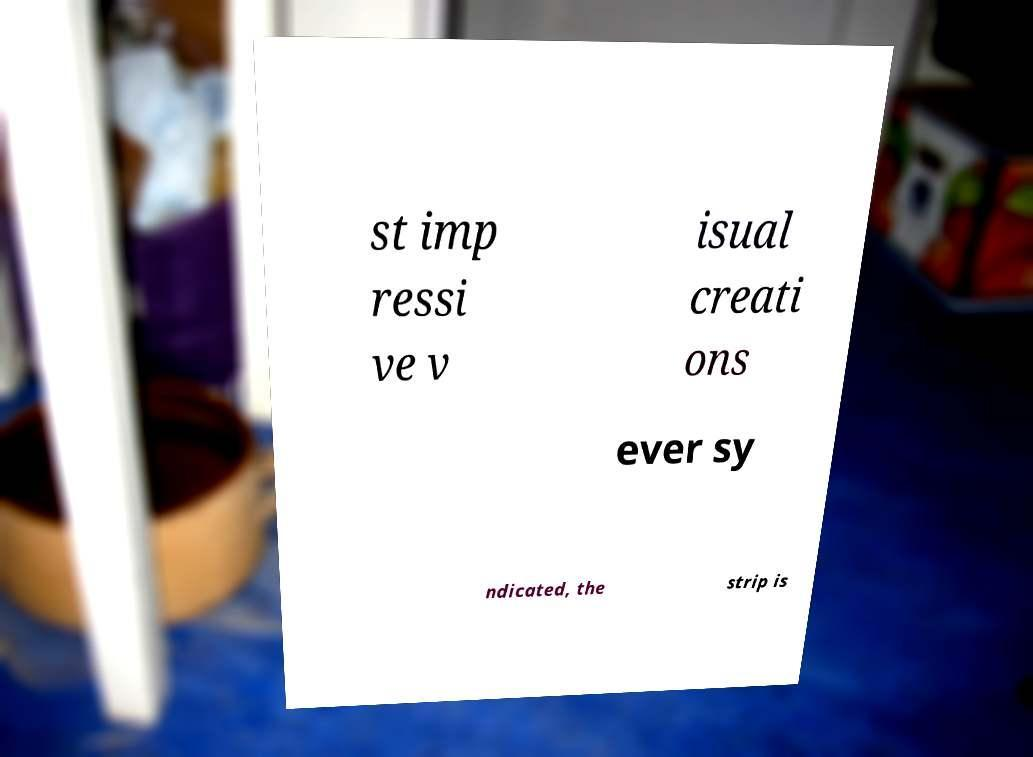Could you extract and type out the text from this image? st imp ressi ve v isual creati ons ever sy ndicated, the strip is 